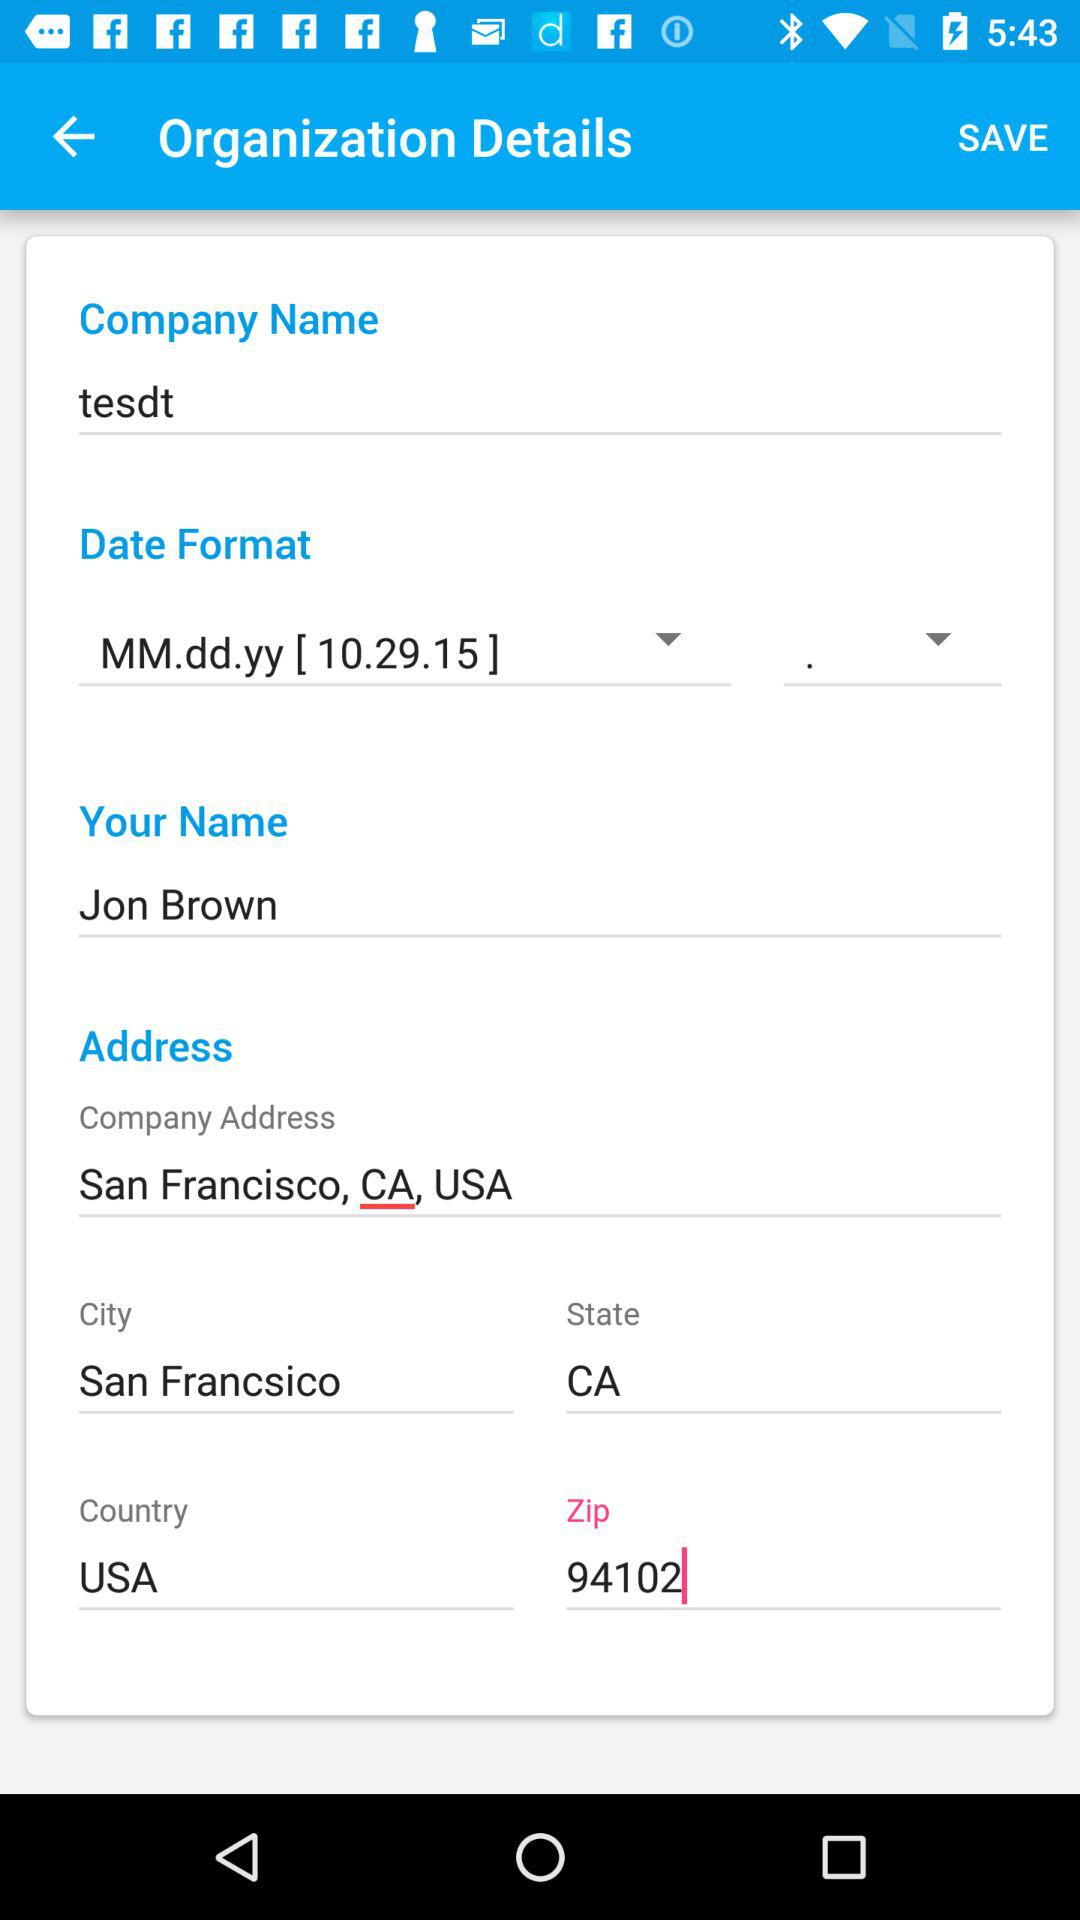What is the state? The state is "CA". 